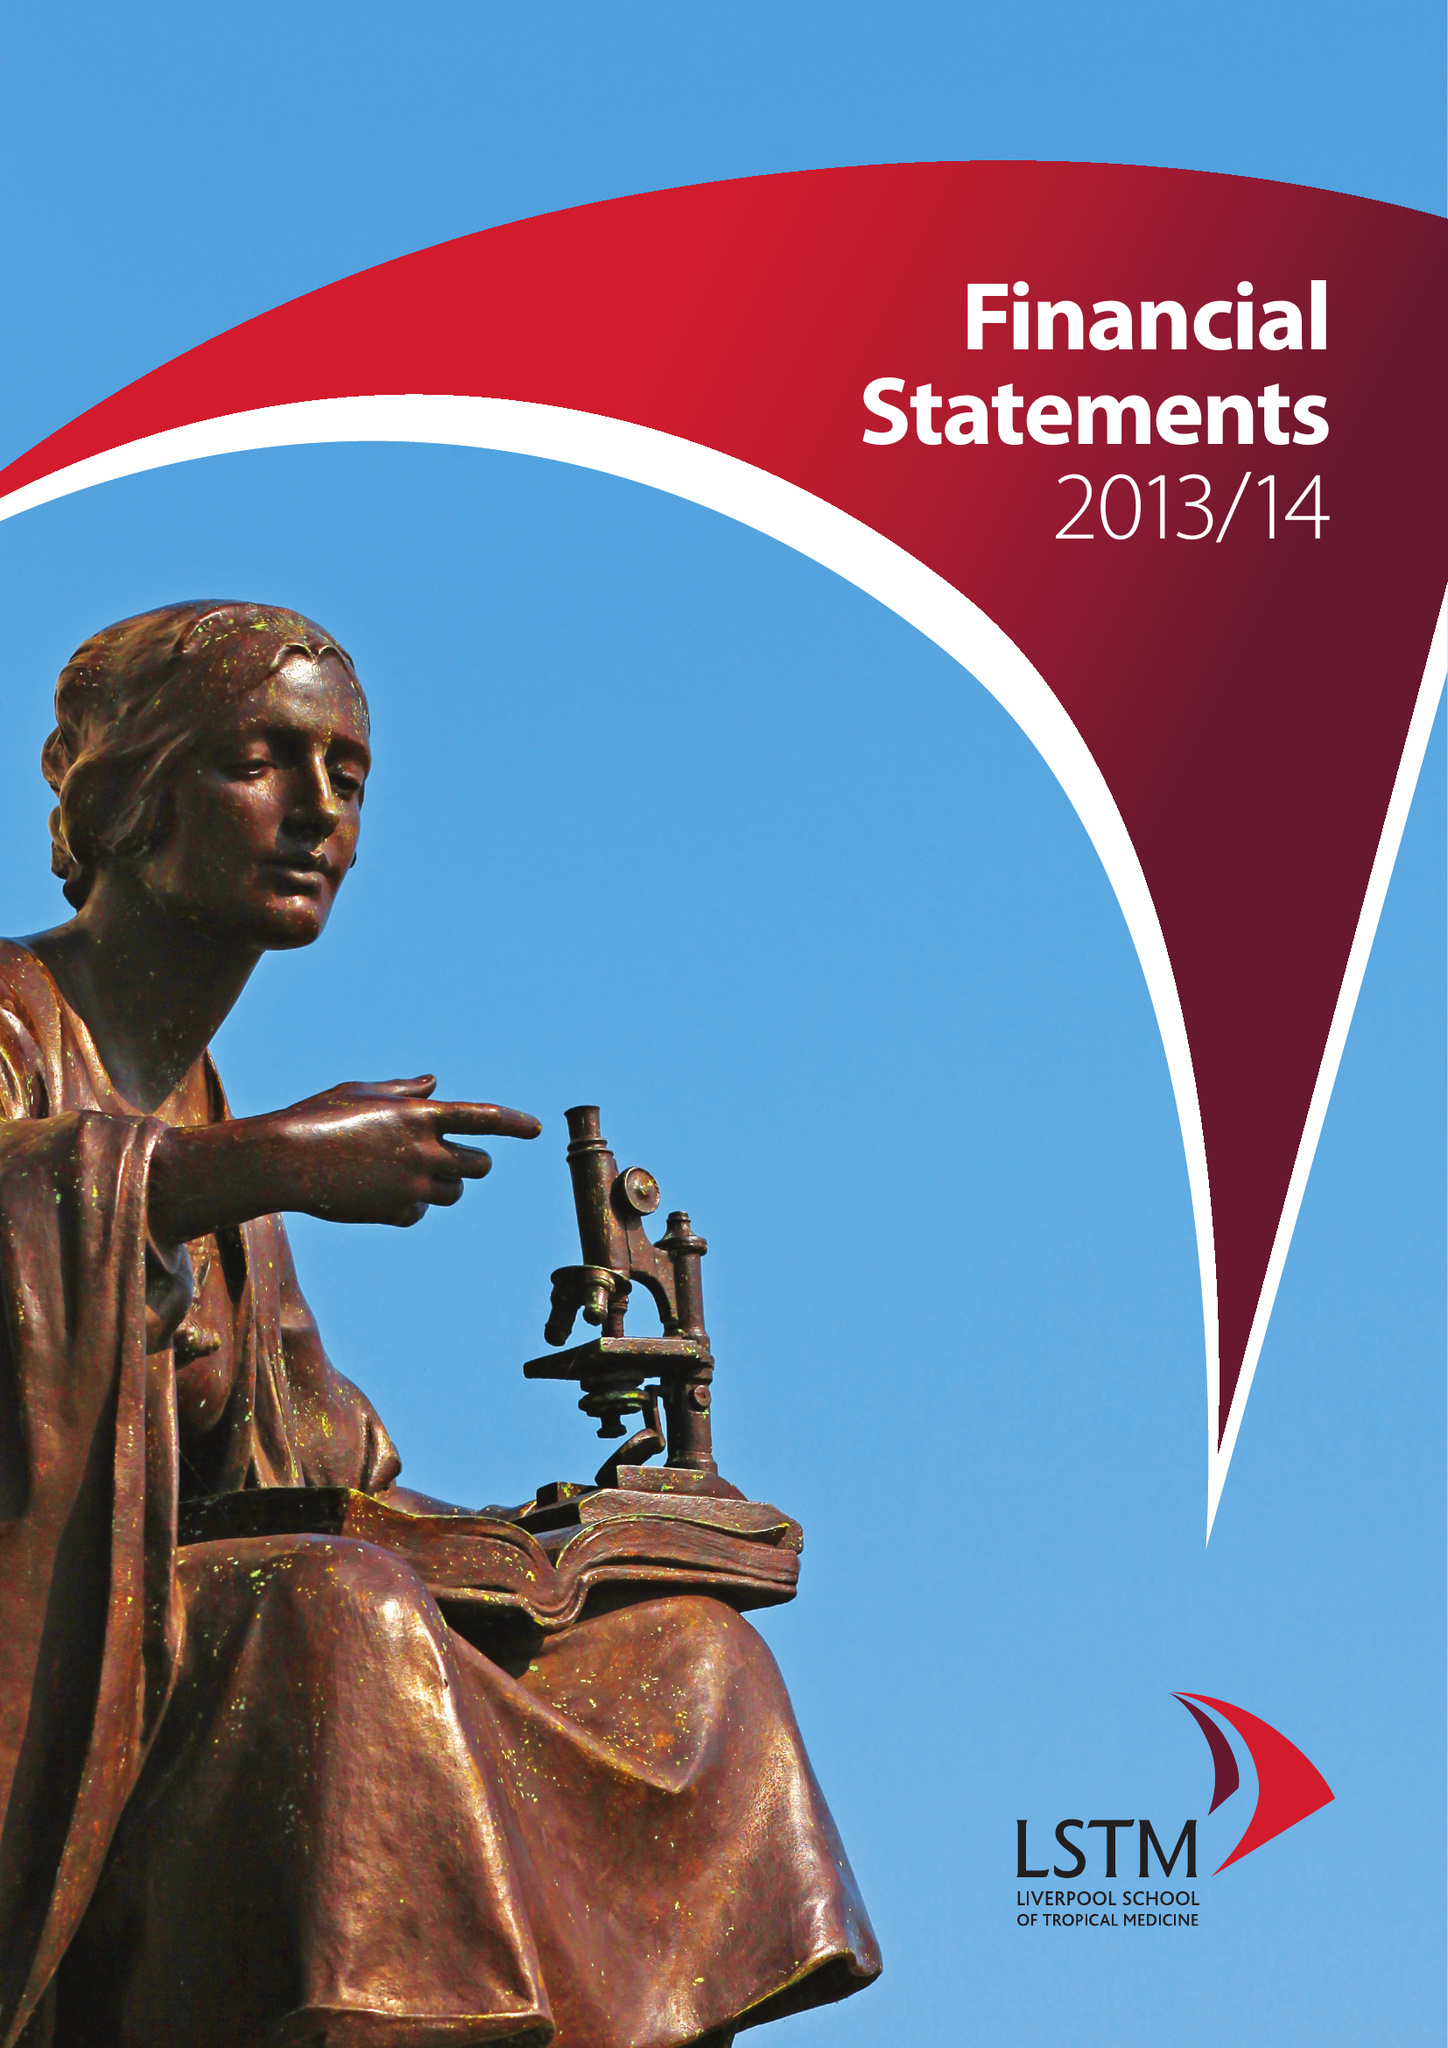What is the value for the charity_name?
Answer the question using a single word or phrase. Liverpool School Of Tropical Medicine 